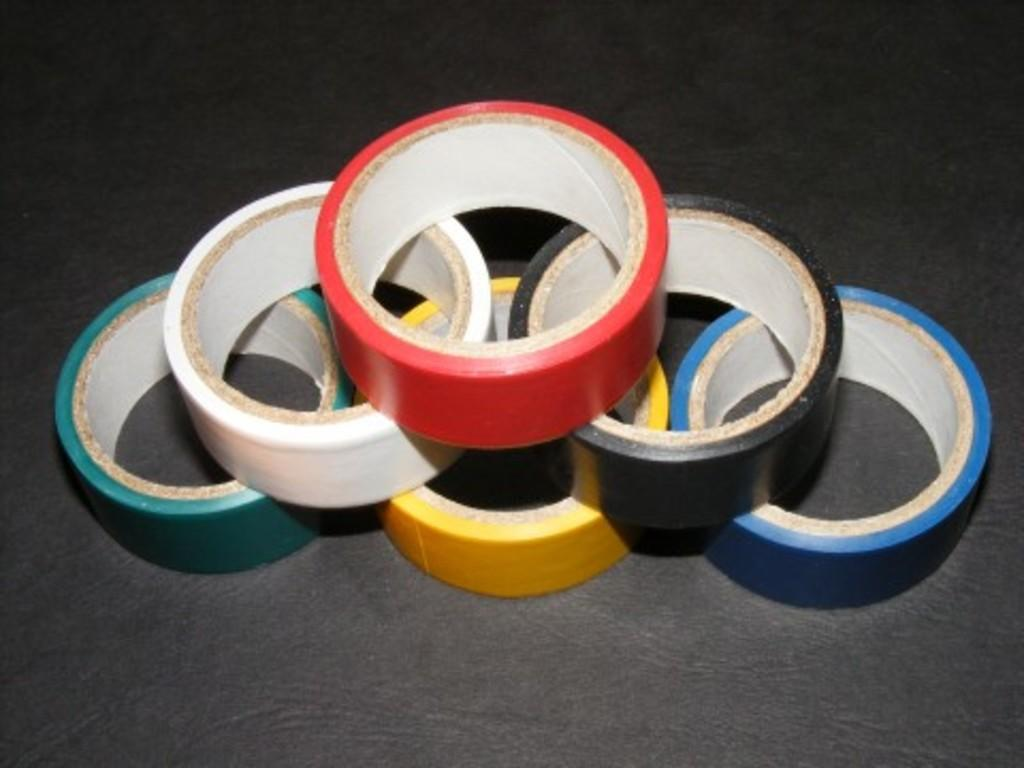What objects are present in the image? There are plaster rolls in the image. Can you describe the appearance of the plaster rolls? The plaster rolls have different colors. What is the color of the background in the image? The background of the image is black. Are there any islands visible in the image? No, there are no islands present in the image. Can you see any bubbles in the image? No, there are no bubbles present in the image. 